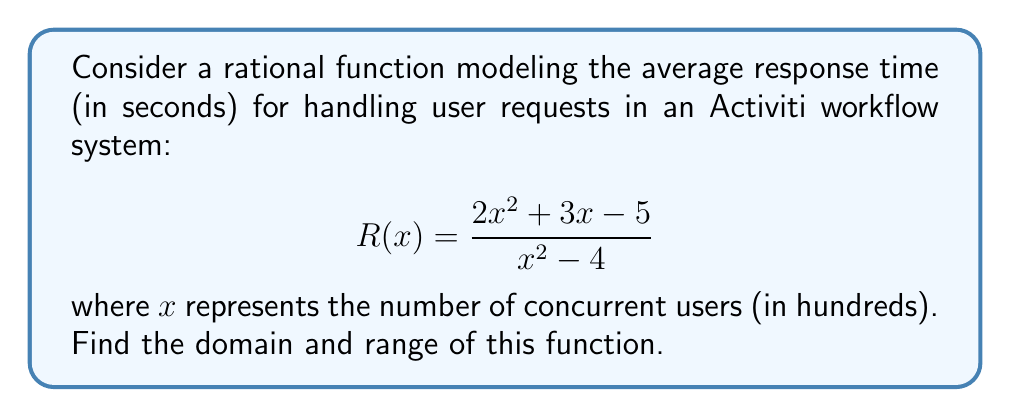Solve this math problem. To find the domain and range of this rational function, we'll follow these steps:

1. Domain:
   The domain consists of all real numbers except those that make the denominator zero.
   
   Set the denominator to zero and solve:
   $$x^2 - 4 = 0$$
   $$(x+2)(x-2) = 0$$
   $$x = -2 \text{ or } x = 2$$
   
   Therefore, the domain is all real numbers except -2 and 2.
   
2. Range:
   To find the range, we'll analyze the behavior of the function:
   
   a) As $x$ approaches infinity or negative infinity:
      $$\lim_{x \to \pm\infty} \frac{2x^2 + 3x - 5}{x^2 - 4} = 2$$
   
   b) Find vertical asymptotes:
      At $x = -2$ and $x = 2$, the function approaches positive or negative infinity.
   
   c) Find horizontal asymptote:
      The horizontal asymptote is y = 2 (from step a).
   
   d) Find the y-intercept:
      When $x = 0$, $R(0) = \frac{-5}{-4} = \frac{5}{4}$
   
   e) Find critical points:
      Set the numerator equal to the denominator multiplied by y:
      $$2x^2 + 3x - 5 = y(x^2 - 4)$$
      $$2x^2 + 3x - 5 = yx^2 - 4y$$
      $$(2-y)x^2 + 3x + (4y-5) = 0$$
      
      For this to have one solution (critical point), the discriminant must be zero:
      $$3^2 - 4(2-y)(4y-5) = 0$$
      $$9 - 8(8y-10-y^2) = 0$$
      $$9 - 64y + 80 + 8y^2 = 0$$
      $$8y^2 - 64y + 89 = 0$$
      $$y = \frac{64 \pm \sqrt{64^2 - 4(8)(89)}}{2(8)} = \frac{64 \pm \sqrt{4096 - 2848}}{16} = \frac{64 \pm \sqrt{1248}}{16}$$
      $$y \approx 5.4019 \text{ or } y \approx 2.5981$$

   The range is all real numbers except the open interval (2.5981, 5.4019).
Answer: Domain: $\mathbb{R} \setminus \{-2, 2\}$
Range: $(-\infty, 2.5981] \cup [5.4019, \infty)$ 